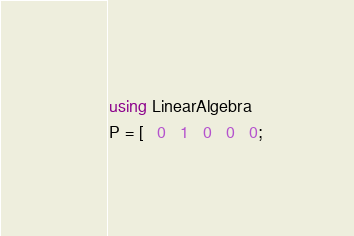Convert code to text. <code><loc_0><loc_0><loc_500><loc_500><_Julia_>using LinearAlgebra
P = [   0   1   0   0   0;</code> 